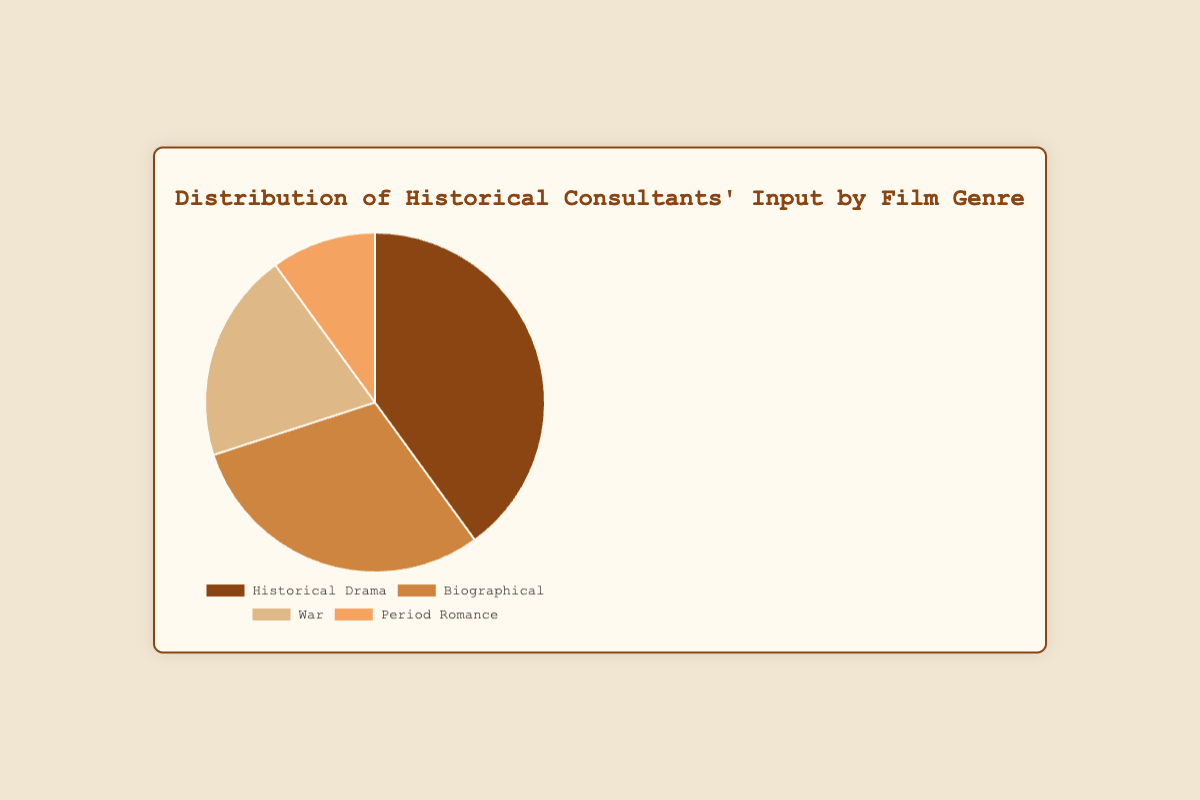Which genre has the highest percentage of Historical Consultants' input? According to the pie chart, the genre with the highest percentage of Historical Consultants' input is "Historical Drama" with 40%.
Answer: Historical Drama Which genre has the lowest percentage of Historical Consultants' input? The pie chart shows that the genre with the lowest percentage of Historical Consultants' input is "Period Romance" with 10%.
Answer: Period Romance What is the total percentage of Historical Consultants' input for Biographical and War films combined? Biographical makes up 30% and War makes up 20%. Summing these percentages, 30% + 20% = 50%.
Answer: 50% How does the percentage of input for Historical Drama compare to Period Romance? Historical Drama has 40% input, while Period Romance has 10%. To compare, 40% is greater than 10%.
Answer: Historical Drama has more input What is the difference in the percentage of input between the genre with the highest and the genre with the lowest input? The highest input is for Historical Drama at 40%, and the lowest is for Period Romance at 10%. The difference is 40% - 10% = 30%.
Answer: 30% What is the average percentage of input across all genres? The percentages are 40%, 30%, 20%, and 10%. Summing these, 40 + 30 + 20 + 10 = 100. Dividing by 4, the average is 100 / 4 = 25%.
Answer: 25% Is the input percentage for Biographical films closer to the percentage for War films or Period Romance films? Biographical has 30%, War has 20%, and Period Romance has 10%. The difference between Biographical and War is 30% - 20% = 10%, and Biographical and Period Romance is 30% - 10% = 20%. Since 10% < 20%, the percentage for Biographical films is closer to War films.
Answer: War films 